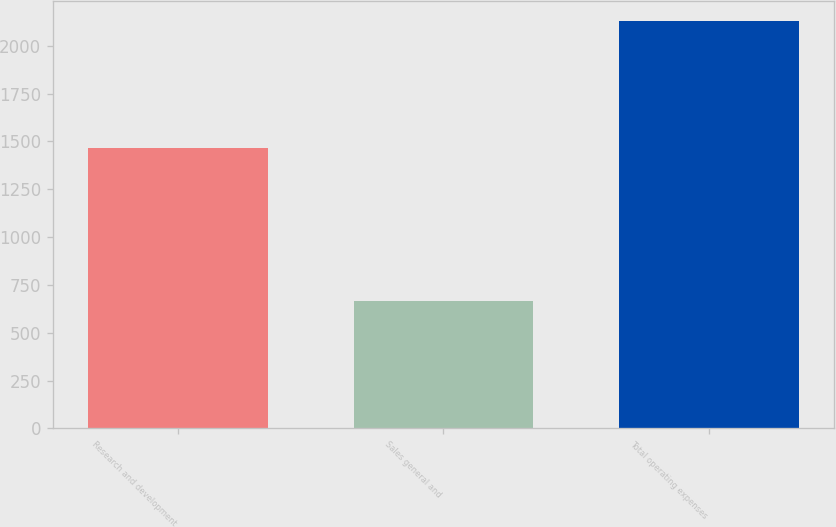Convert chart to OTSL. <chart><loc_0><loc_0><loc_500><loc_500><bar_chart><fcel>Research and development<fcel>Sales general and<fcel>Total operating expenses<nl><fcel>1463<fcel>663<fcel>2129<nl></chart> 